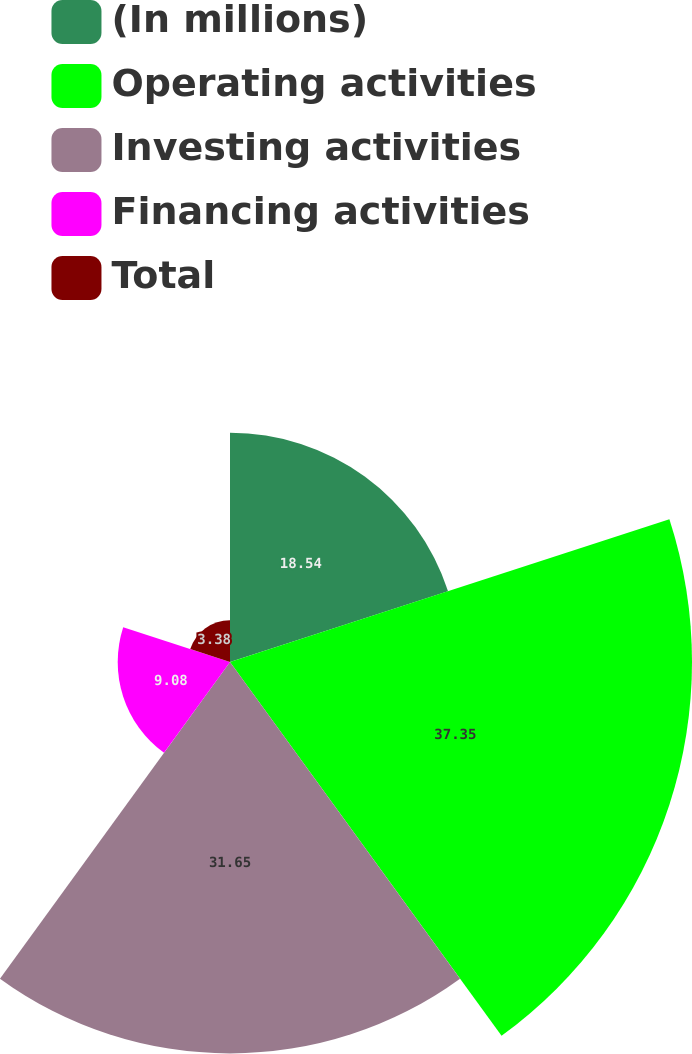<chart> <loc_0><loc_0><loc_500><loc_500><pie_chart><fcel>(In millions)<fcel>Operating activities<fcel>Investing activities<fcel>Financing activities<fcel>Total<nl><fcel>18.54%<fcel>37.36%<fcel>31.65%<fcel>9.08%<fcel>3.38%<nl></chart> 